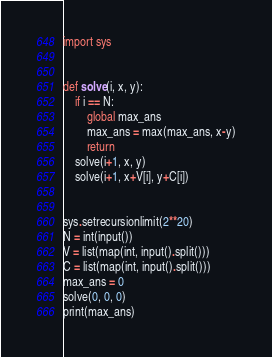Convert code to text. <code><loc_0><loc_0><loc_500><loc_500><_Python_>import sys


def solve(i, x, y):
    if i == N:
        global max_ans
        max_ans = max(max_ans, x-y)
        return
    solve(i+1, x, y)
    solve(i+1, x+V[i], y+C[i])


sys.setrecursionlimit(2**20)
N = int(input())
V = list(map(int, input().split()))
C = list(map(int, input().split()))
max_ans = 0
solve(0, 0, 0)
print(max_ans)</code> 